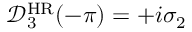<formula> <loc_0><loc_0><loc_500><loc_500>\mathcal { D } _ { 3 } ^ { H R } ( - \pi ) = + i \sigma _ { 2 }</formula> 